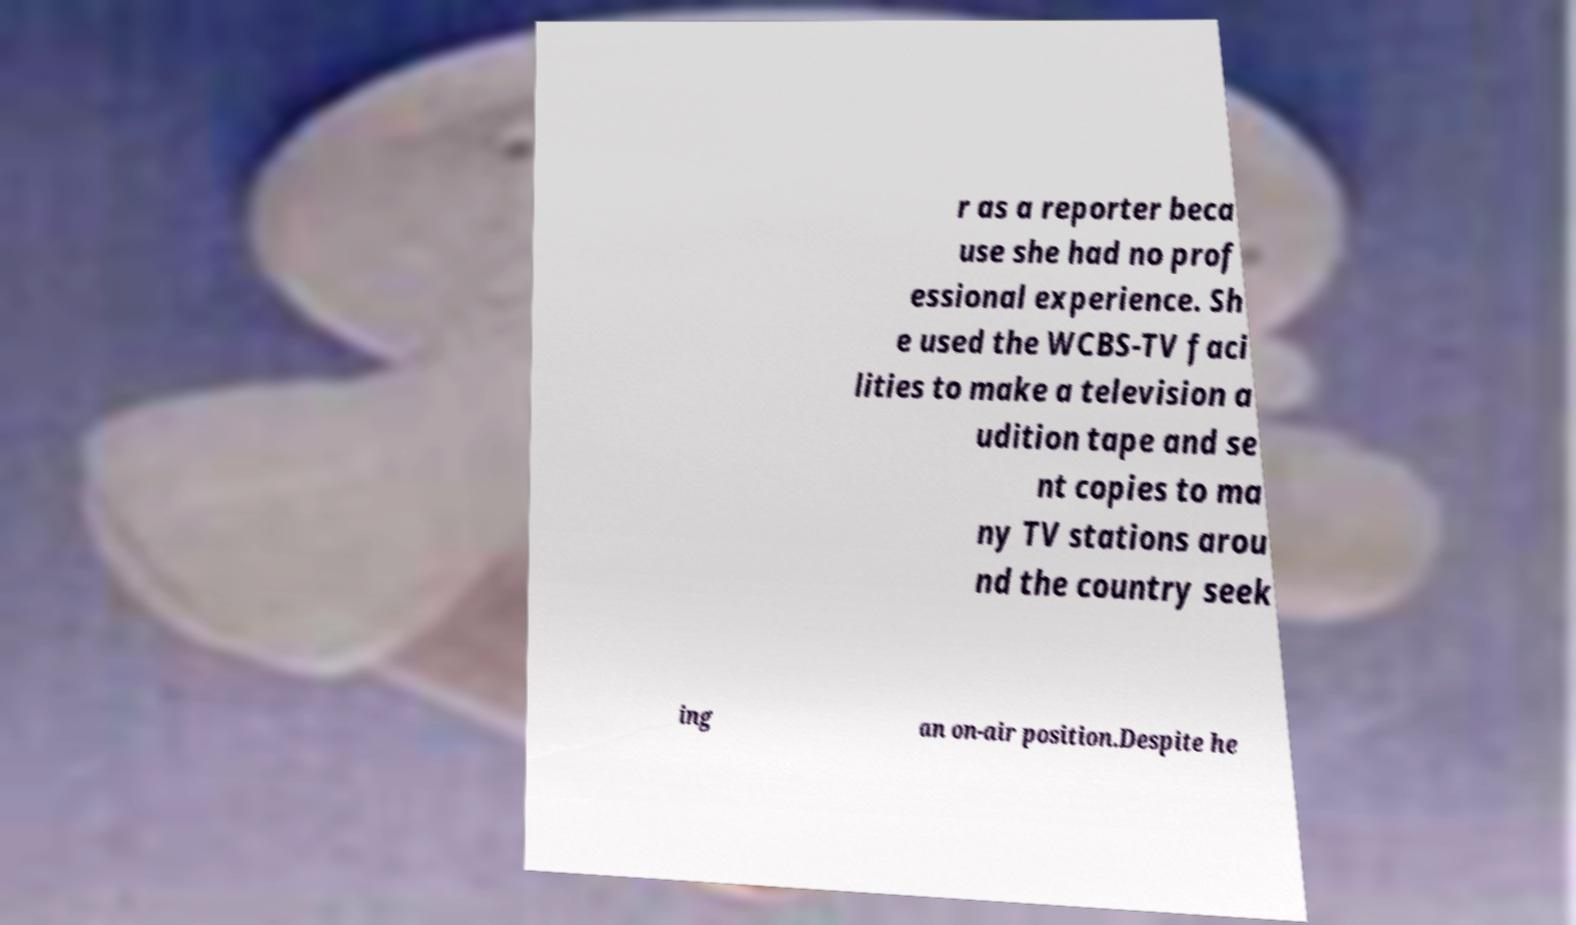Please read and relay the text visible in this image. What does it say? r as a reporter beca use she had no prof essional experience. Sh e used the WCBS-TV faci lities to make a television a udition tape and se nt copies to ma ny TV stations arou nd the country seek ing an on-air position.Despite he 